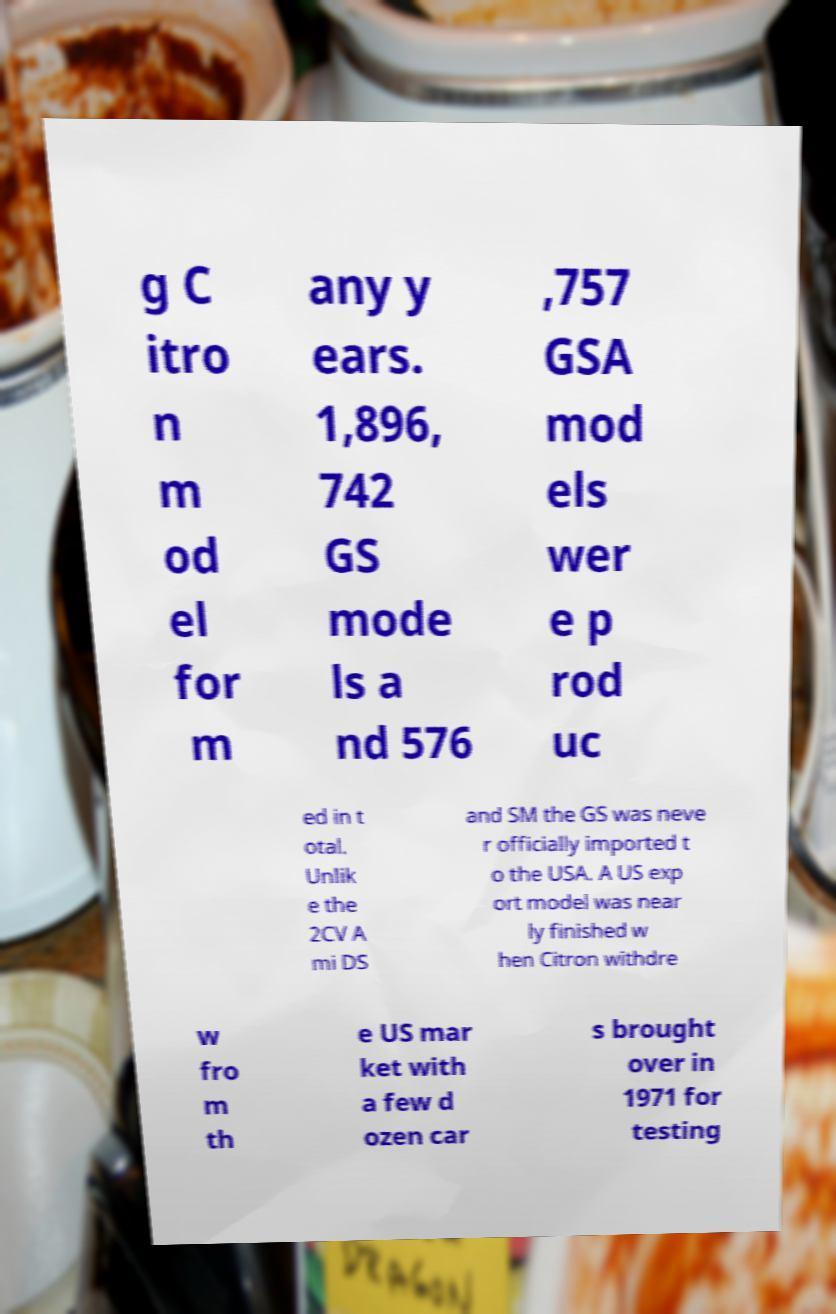For documentation purposes, I need the text within this image transcribed. Could you provide that? g C itro n m od el for m any y ears. 1,896, 742 GS mode ls a nd 576 ,757 GSA mod els wer e p rod uc ed in t otal. Unlik e the 2CV A mi DS and SM the GS was neve r officially imported t o the USA. A US exp ort model was near ly finished w hen Citron withdre w fro m th e US mar ket with a few d ozen car s brought over in 1971 for testing 